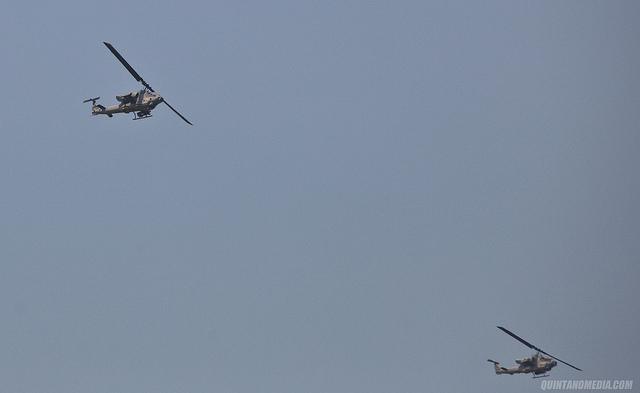Are the planes flying in formation?
Keep it brief. Yes. What is the object flying in front of the plane?
Short answer required. Helicopter. Is the sky blue with white jet trails?
Keep it brief. No. What type of vehicles are these?
Write a very short answer. Helicopters. Are the planes in formation?
Give a very brief answer. Yes. Are the planes flying close to each other?
Concise answer only. Yes. What is in the sky?
Quick response, please. Helicopters. What vehicle is shown?
Keep it brief. Helicopter. What color is the sky?
Short answer required. Blue. How many vehicles are in this picture?
Be succinct. 2. Are the aircrafts synchronized?
Answer briefly. Yes. 